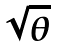Convert formula to latex. <formula><loc_0><loc_0><loc_500><loc_500>\sqrt { \theta }</formula> 